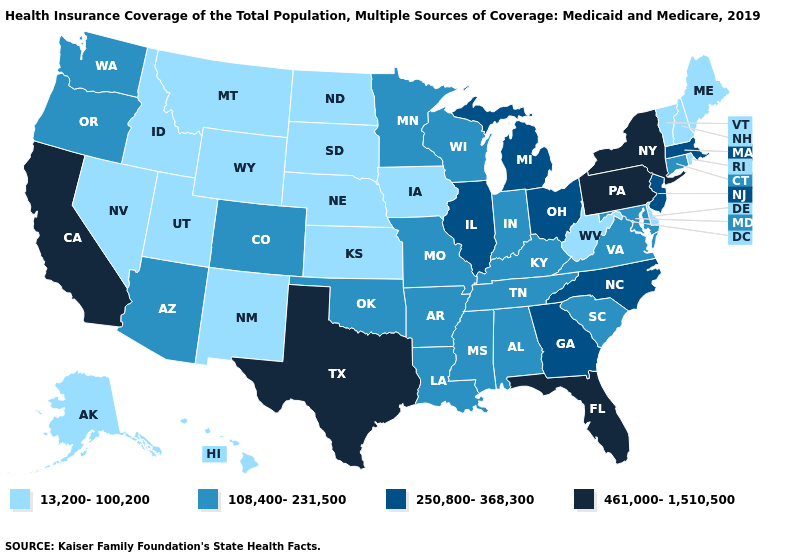What is the lowest value in the West?
Be succinct. 13,200-100,200. Does Tennessee have the highest value in the USA?
Be succinct. No. Is the legend a continuous bar?
Short answer required. No. Name the states that have a value in the range 461,000-1,510,500?
Short answer required. California, Florida, New York, Pennsylvania, Texas. Does California have the highest value in the West?
Answer briefly. Yes. What is the value of New York?
Answer briefly. 461,000-1,510,500. What is the value of Kentucky?
Give a very brief answer. 108,400-231,500. Does California have a lower value than Nebraska?
Give a very brief answer. No. What is the value of Wisconsin?
Write a very short answer. 108,400-231,500. What is the value of Michigan?
Concise answer only. 250,800-368,300. Does the map have missing data?
Concise answer only. No. Does Virginia have a lower value than Georgia?
Short answer required. Yes. What is the value of Delaware?
Give a very brief answer. 13,200-100,200. Name the states that have a value in the range 250,800-368,300?
Quick response, please. Georgia, Illinois, Massachusetts, Michigan, New Jersey, North Carolina, Ohio. What is the value of Alabama?
Give a very brief answer. 108,400-231,500. 